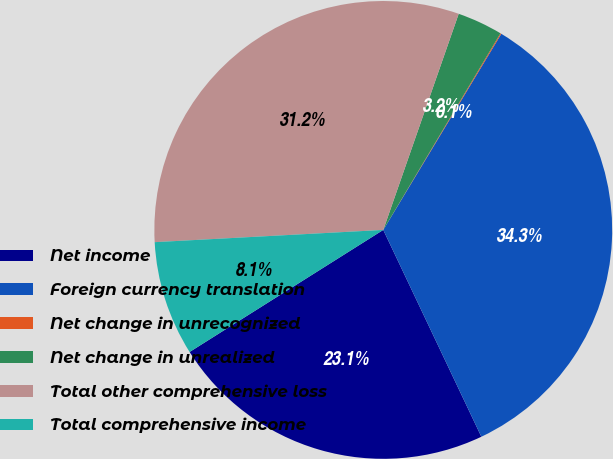Convert chart to OTSL. <chart><loc_0><loc_0><loc_500><loc_500><pie_chart><fcel>Net income<fcel>Foreign currency translation<fcel>Net change in unrecognized<fcel>Net change in unrealized<fcel>Total other comprehensive loss<fcel>Total comprehensive income<nl><fcel>23.1%<fcel>34.33%<fcel>0.07%<fcel>3.21%<fcel>31.2%<fcel>8.1%<nl></chart> 